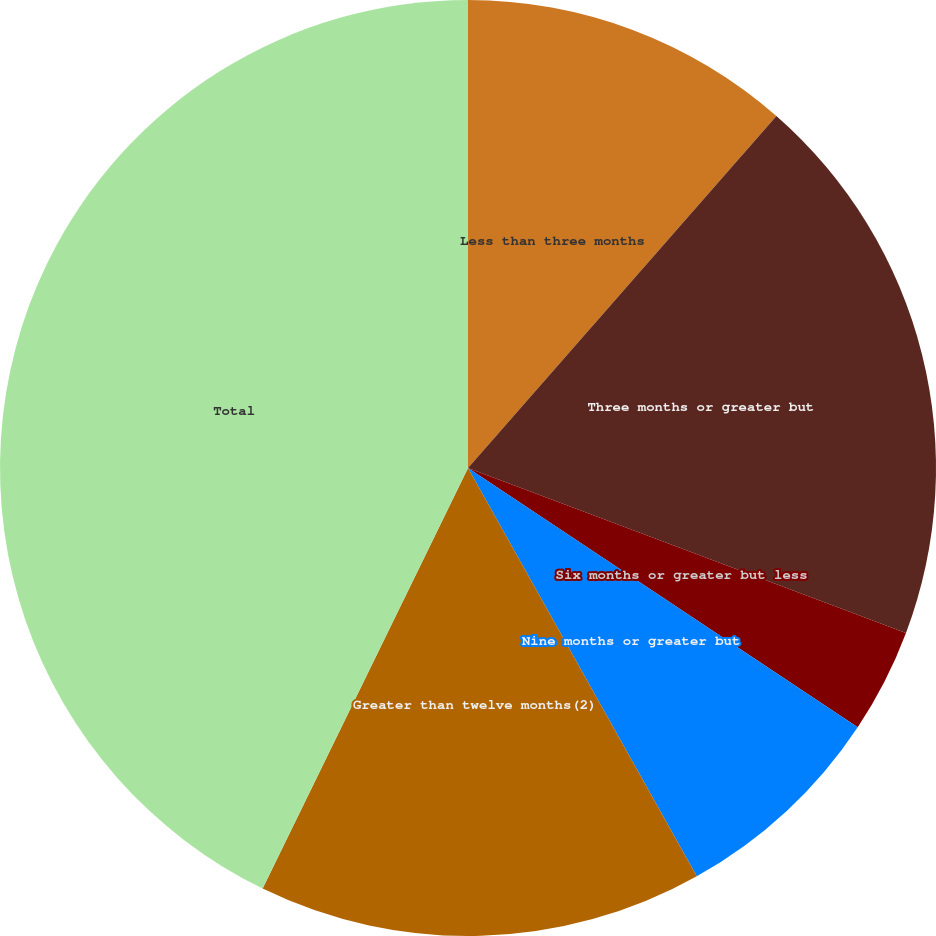Convert chart to OTSL. <chart><loc_0><loc_0><loc_500><loc_500><pie_chart><fcel>Less than three months<fcel>Three months or greater but<fcel>Six months or greater but less<fcel>Nine months or greater but<fcel>Greater than twelve months(2)<fcel>Total<nl><fcel>11.45%<fcel>19.28%<fcel>3.61%<fcel>7.53%<fcel>15.36%<fcel>42.77%<nl></chart> 